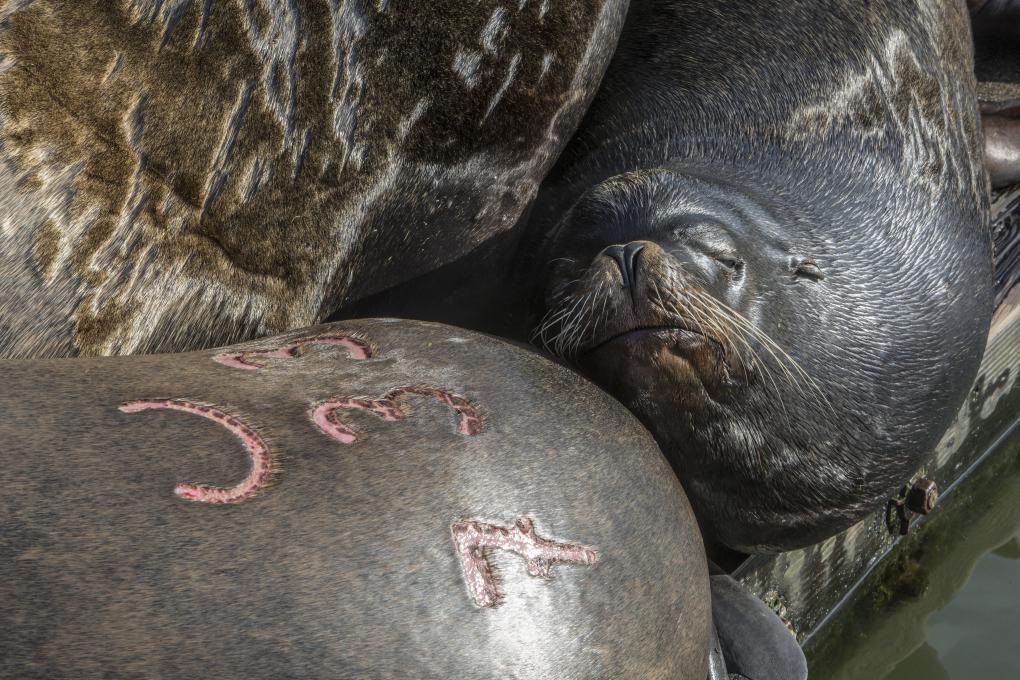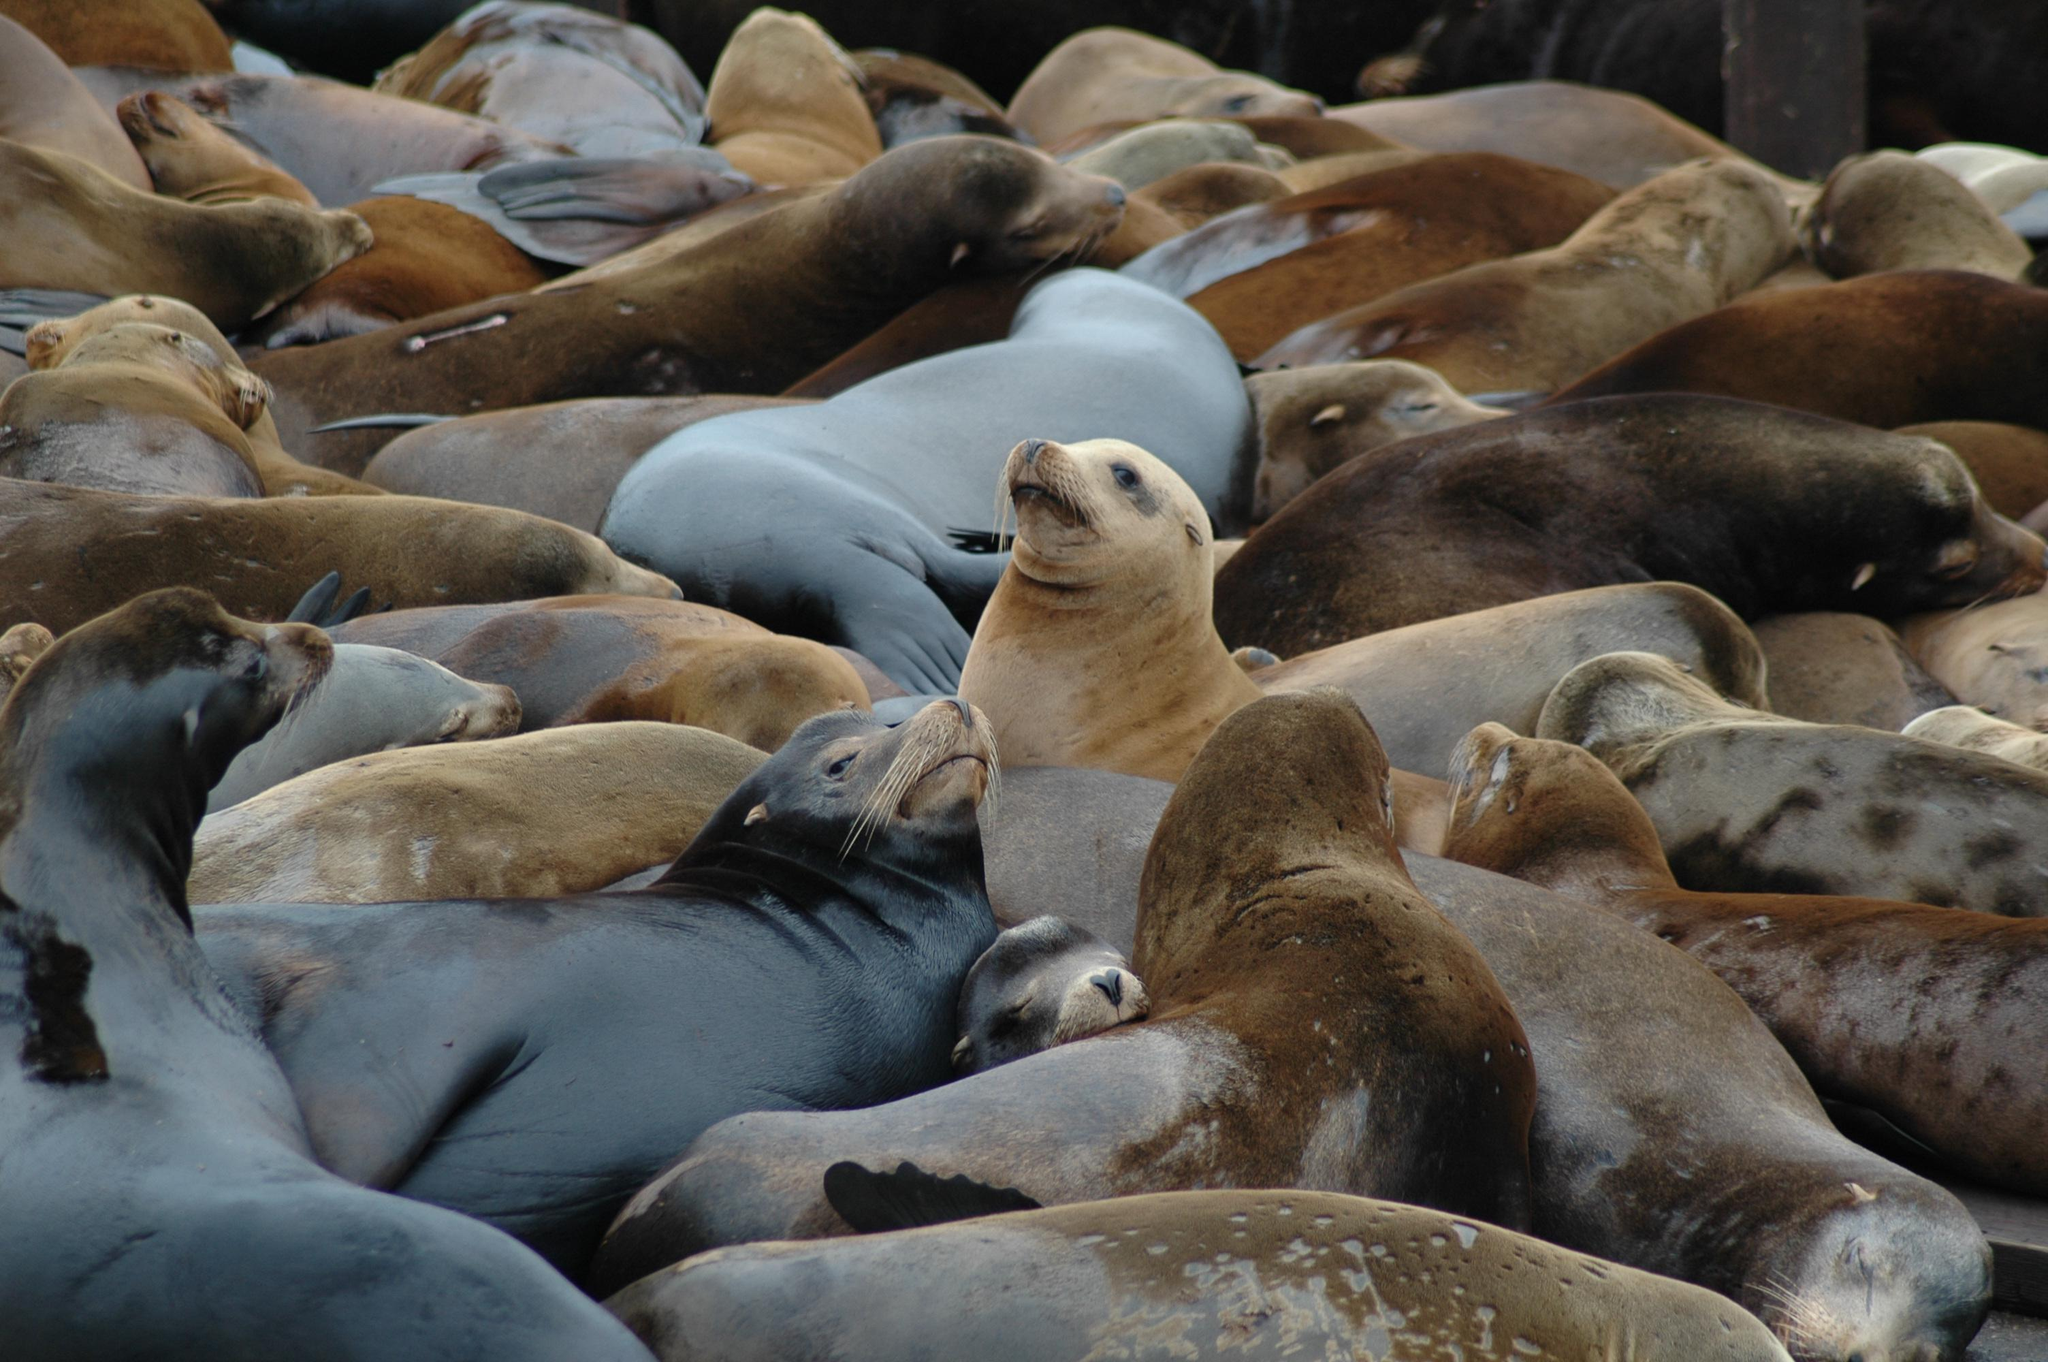The first image is the image on the left, the second image is the image on the right. Considering the images on both sides, is "An image contains no more than one seal." valid? Answer yes or no. No. The first image is the image on the left, the second image is the image on the right. For the images displayed, is the sentence "Some of the sea lions have markings made by humans on them." factually correct? Answer yes or no. Yes. 